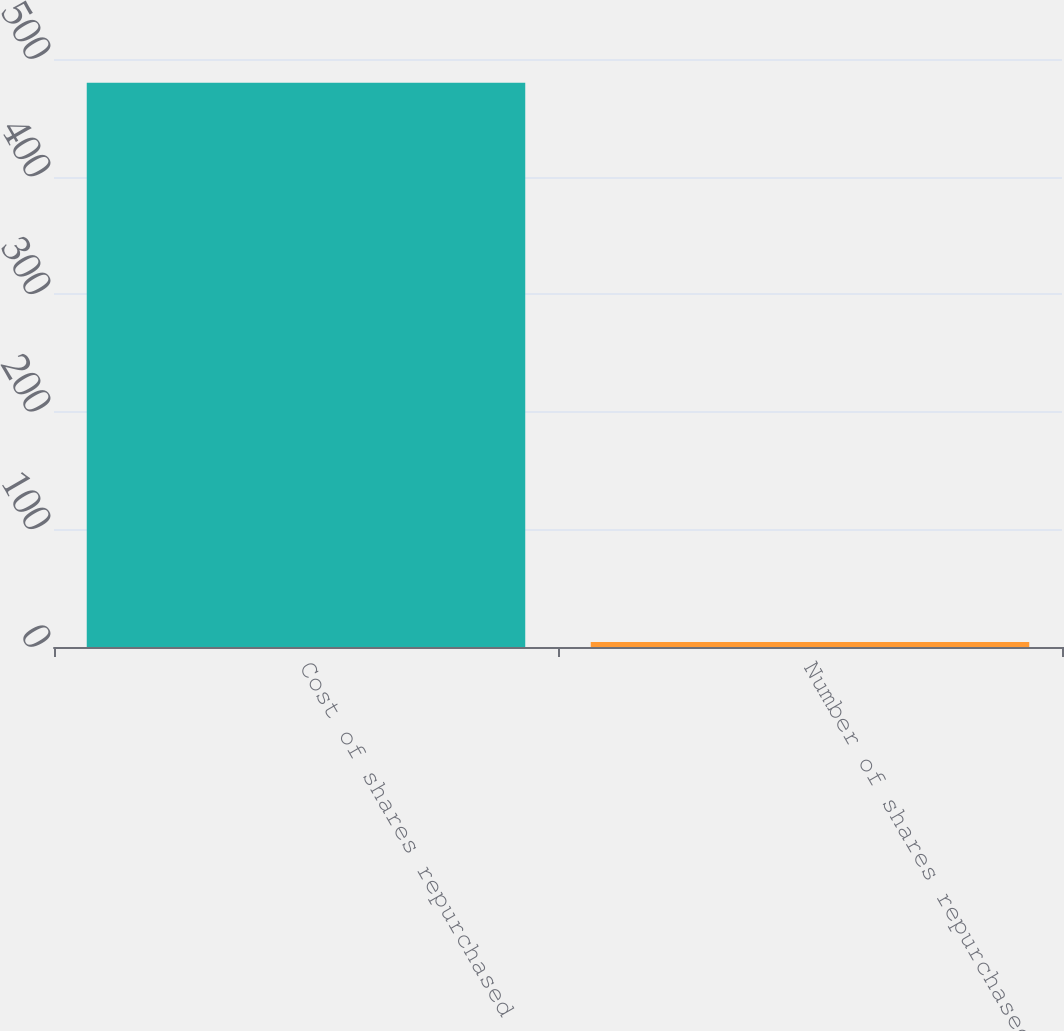Convert chart. <chart><loc_0><loc_0><loc_500><loc_500><bar_chart><fcel>Cost of shares repurchased<fcel>Number of shares repurchased<nl><fcel>479.9<fcel>4.2<nl></chart> 